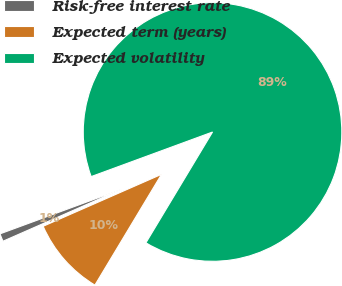Convert chart. <chart><loc_0><loc_0><loc_500><loc_500><pie_chart><fcel>Risk-free interest rate<fcel>Expected term (years)<fcel>Expected volatility<nl><fcel>0.98%<fcel>9.8%<fcel>89.22%<nl></chart> 